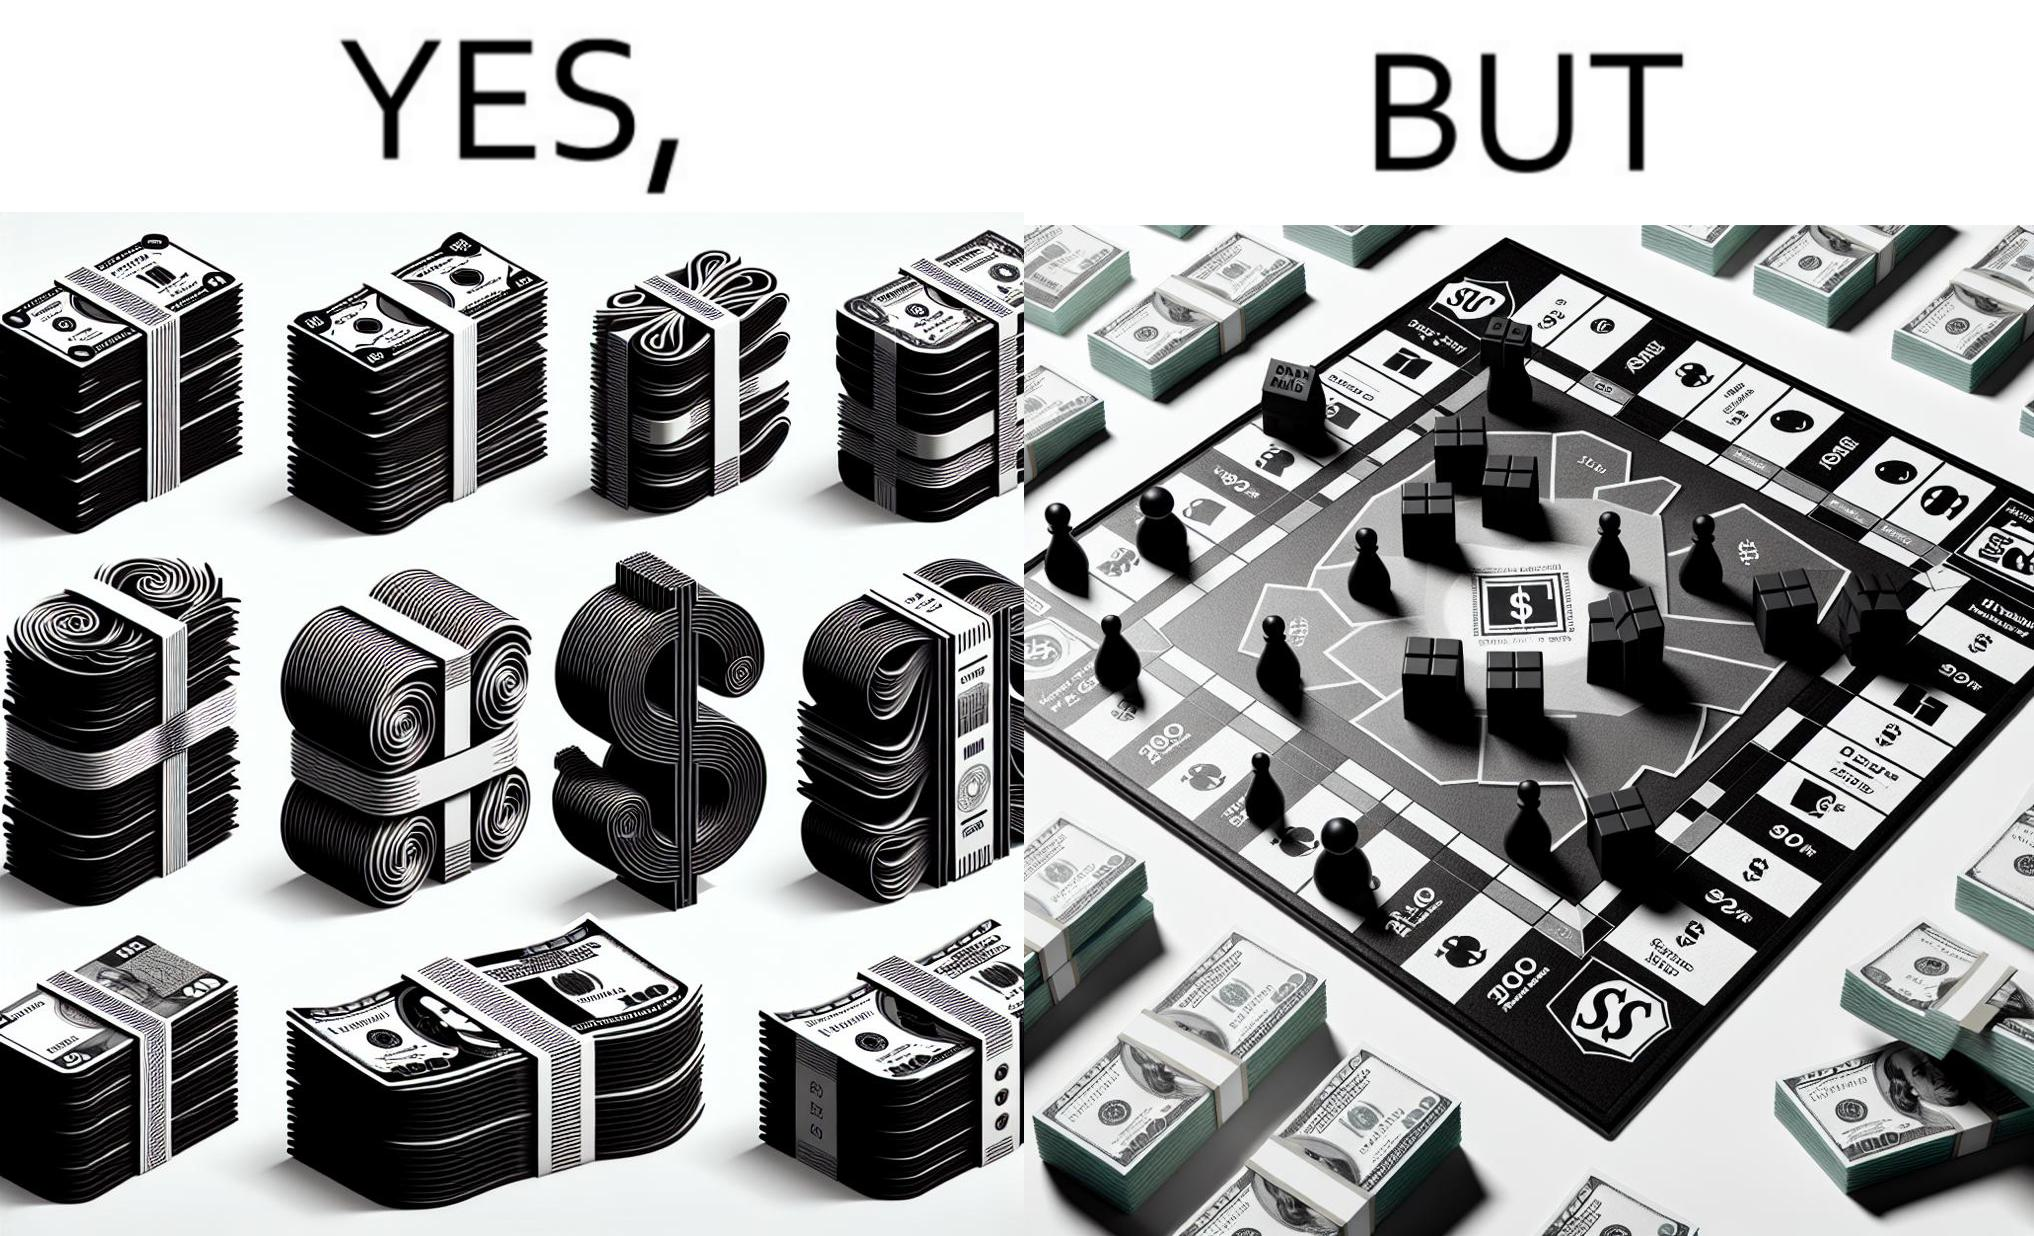What is the satirical meaning behind this image? The image is ironic, because there are many different color currency notes' bundles but they are just as a currency in the game of monopoly and they have no real value 